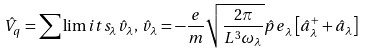Convert formula to latex. <formula><loc_0><loc_0><loc_500><loc_500>\hat { V } _ { q } = \sum \lim i t s _ { \lambda } { \hat { v } _ { \lambda } } , \, \hat { v } _ { \lambda } = - \frac { e } { m } \sqrt { \frac { 2 \pi } { L ^ { 3 } \omega _ { \lambda } } } { \hat { p } e } _ { \lambda } \left [ { \hat { a } _ { \lambda } ^ { + } + \hat { a } _ { \lambda } } \right ]</formula> 